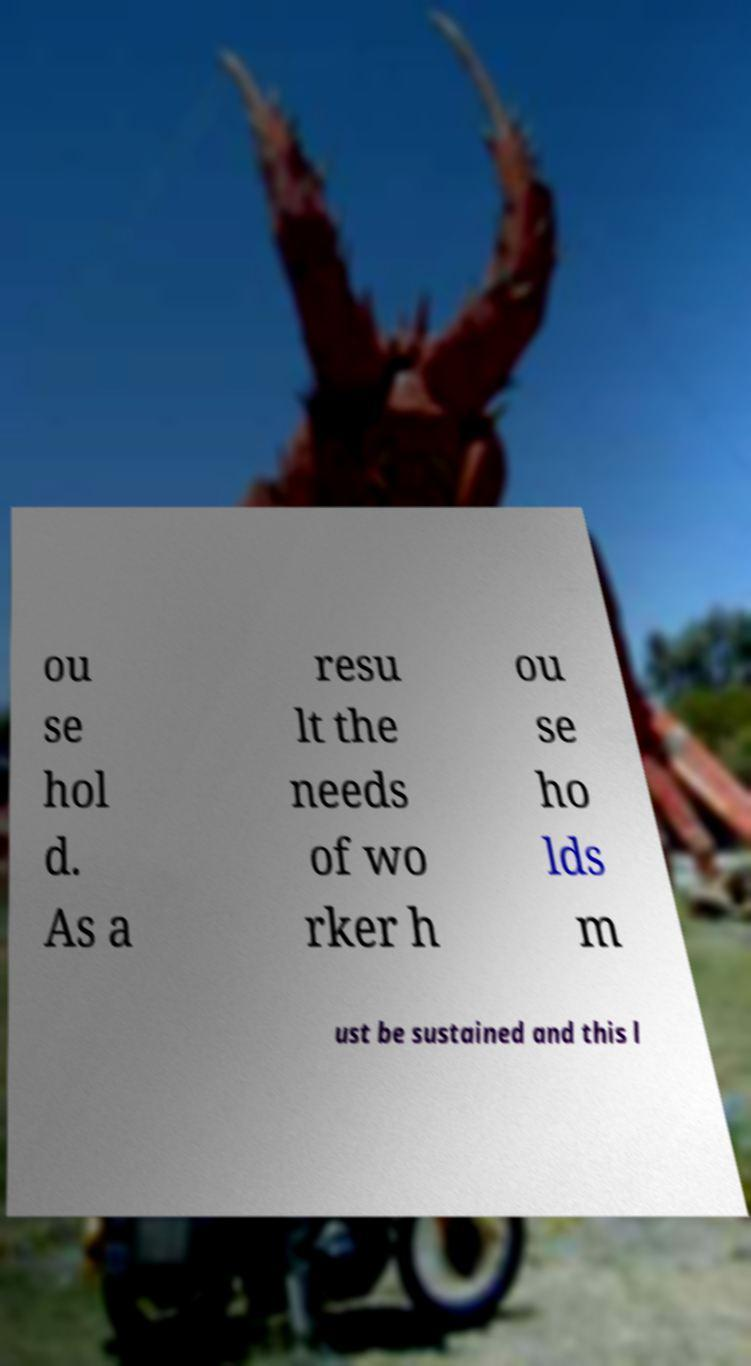Can you read and provide the text displayed in the image?This photo seems to have some interesting text. Can you extract and type it out for me? ou se hol d. As a resu lt the needs of wo rker h ou se ho lds m ust be sustained and this l 